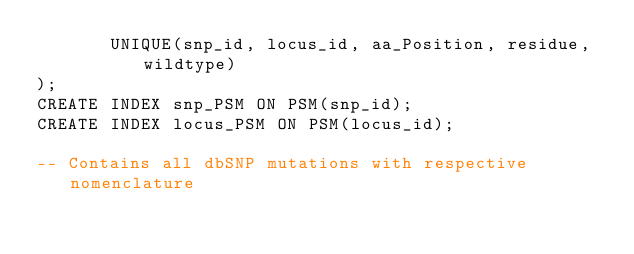Convert code to text. <code><loc_0><loc_0><loc_500><loc_500><_SQL_>       UNIQUE(snp_id, locus_id, aa_Position, residue, wildtype)
);
CREATE INDEX snp_PSM ON PSM(snp_id);
CREATE INDEX locus_PSM ON PSM(locus_id);

-- Contains all dbSNP mutations with respective nomenclature </code> 